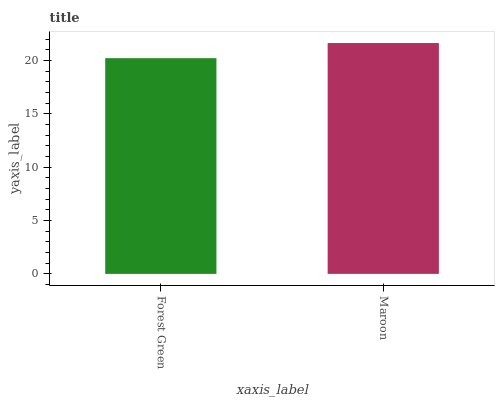Is Forest Green the minimum?
Answer yes or no. Yes. Is Maroon the maximum?
Answer yes or no. Yes. Is Maroon the minimum?
Answer yes or no. No. Is Maroon greater than Forest Green?
Answer yes or no. Yes. Is Forest Green less than Maroon?
Answer yes or no. Yes. Is Forest Green greater than Maroon?
Answer yes or no. No. Is Maroon less than Forest Green?
Answer yes or no. No. Is Maroon the high median?
Answer yes or no. Yes. Is Forest Green the low median?
Answer yes or no. Yes. Is Forest Green the high median?
Answer yes or no. No. Is Maroon the low median?
Answer yes or no. No. 